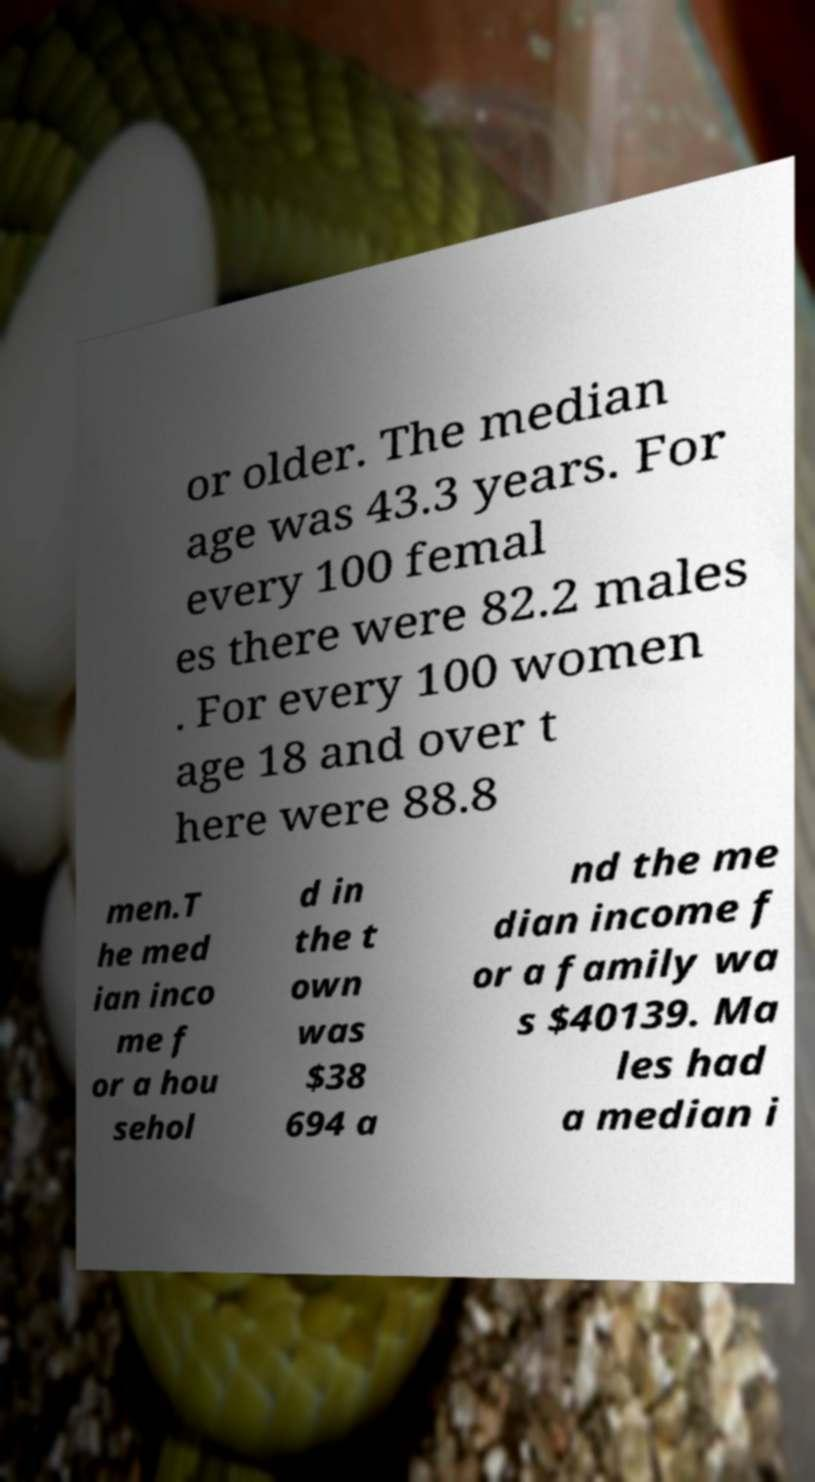Could you extract and type out the text from this image? or older. The median age was 43.3 years. For every 100 femal es there were 82.2 males . For every 100 women age 18 and over t here were 88.8 men.T he med ian inco me f or a hou sehol d in the t own was $38 694 a nd the me dian income f or a family wa s $40139. Ma les had a median i 